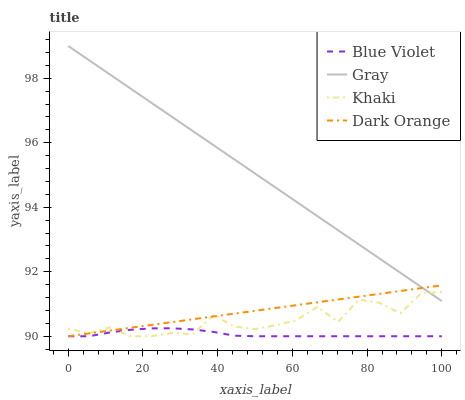Does Blue Violet have the minimum area under the curve?
Answer yes or no. Yes. Does Gray have the maximum area under the curve?
Answer yes or no. Yes. Does Khaki have the minimum area under the curve?
Answer yes or no. No. Does Khaki have the maximum area under the curve?
Answer yes or no. No. Is Gray the smoothest?
Answer yes or no. Yes. Is Khaki the roughest?
Answer yes or no. Yes. Is Blue Violet the smoothest?
Answer yes or no. No. Is Blue Violet the roughest?
Answer yes or no. No. Does Khaki have the lowest value?
Answer yes or no. Yes. Does Gray have the highest value?
Answer yes or no. Yes. Does Khaki have the highest value?
Answer yes or no. No. Is Blue Violet less than Gray?
Answer yes or no. Yes. Is Gray greater than Blue Violet?
Answer yes or no. Yes. Does Khaki intersect Dark Orange?
Answer yes or no. Yes. Is Khaki less than Dark Orange?
Answer yes or no. No. Is Khaki greater than Dark Orange?
Answer yes or no. No. Does Blue Violet intersect Gray?
Answer yes or no. No. 